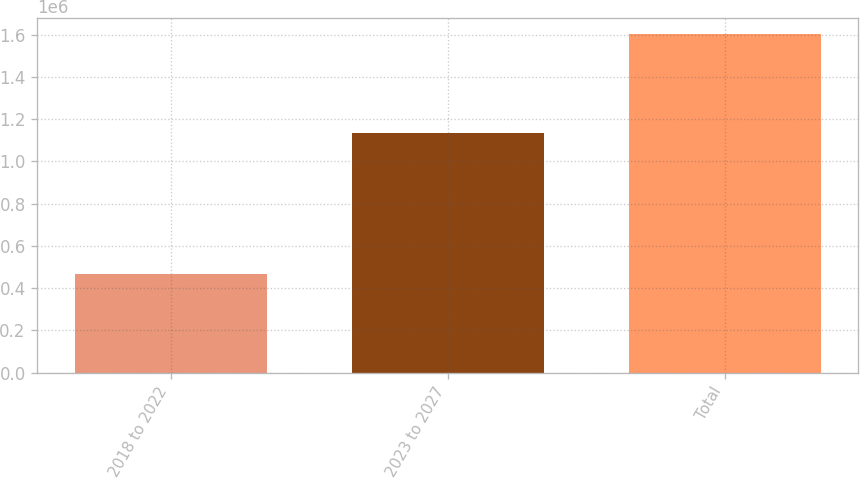Convert chart to OTSL. <chart><loc_0><loc_0><loc_500><loc_500><bar_chart><fcel>2018 to 2022<fcel>2023 to 2027<fcel>Total<nl><fcel>466747<fcel>1.13406e+06<fcel>1.60081e+06<nl></chart> 